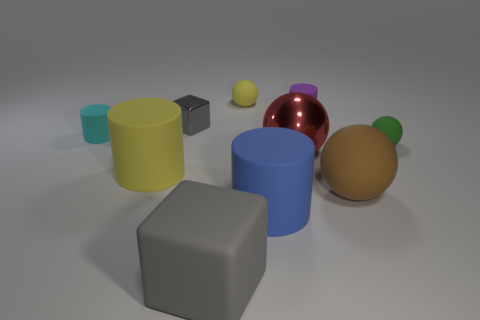Subtract all green spheres. How many spheres are left? 3 Subtract all yellow cubes. How many cyan balls are left? 0 Subtract all green spheres. How many spheres are left? 3 Subtract 0 red blocks. How many objects are left? 10 Subtract all balls. How many objects are left? 6 Subtract 1 cylinders. How many cylinders are left? 3 Subtract all green cylinders. Subtract all red cubes. How many cylinders are left? 4 Subtract all big rubber balls. Subtract all yellow balls. How many objects are left? 8 Add 4 gray matte objects. How many gray matte objects are left? 5 Add 8 big gray rubber spheres. How many big gray rubber spheres exist? 8 